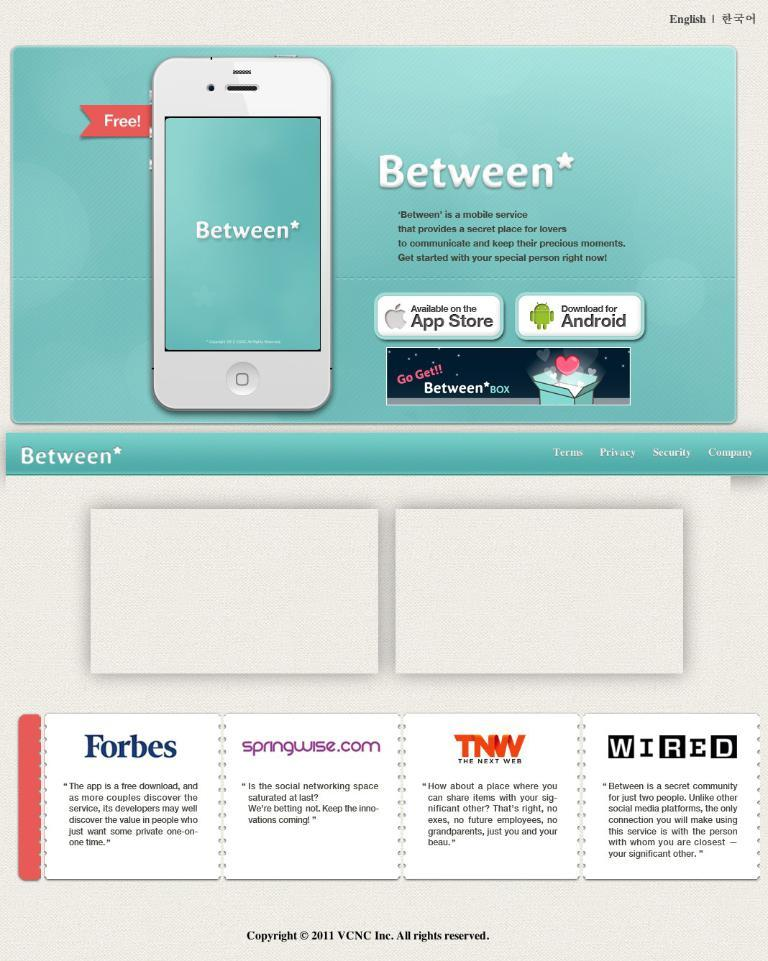<image>
Provide a brief description of the given image. An ad for a mobile service called Between. 